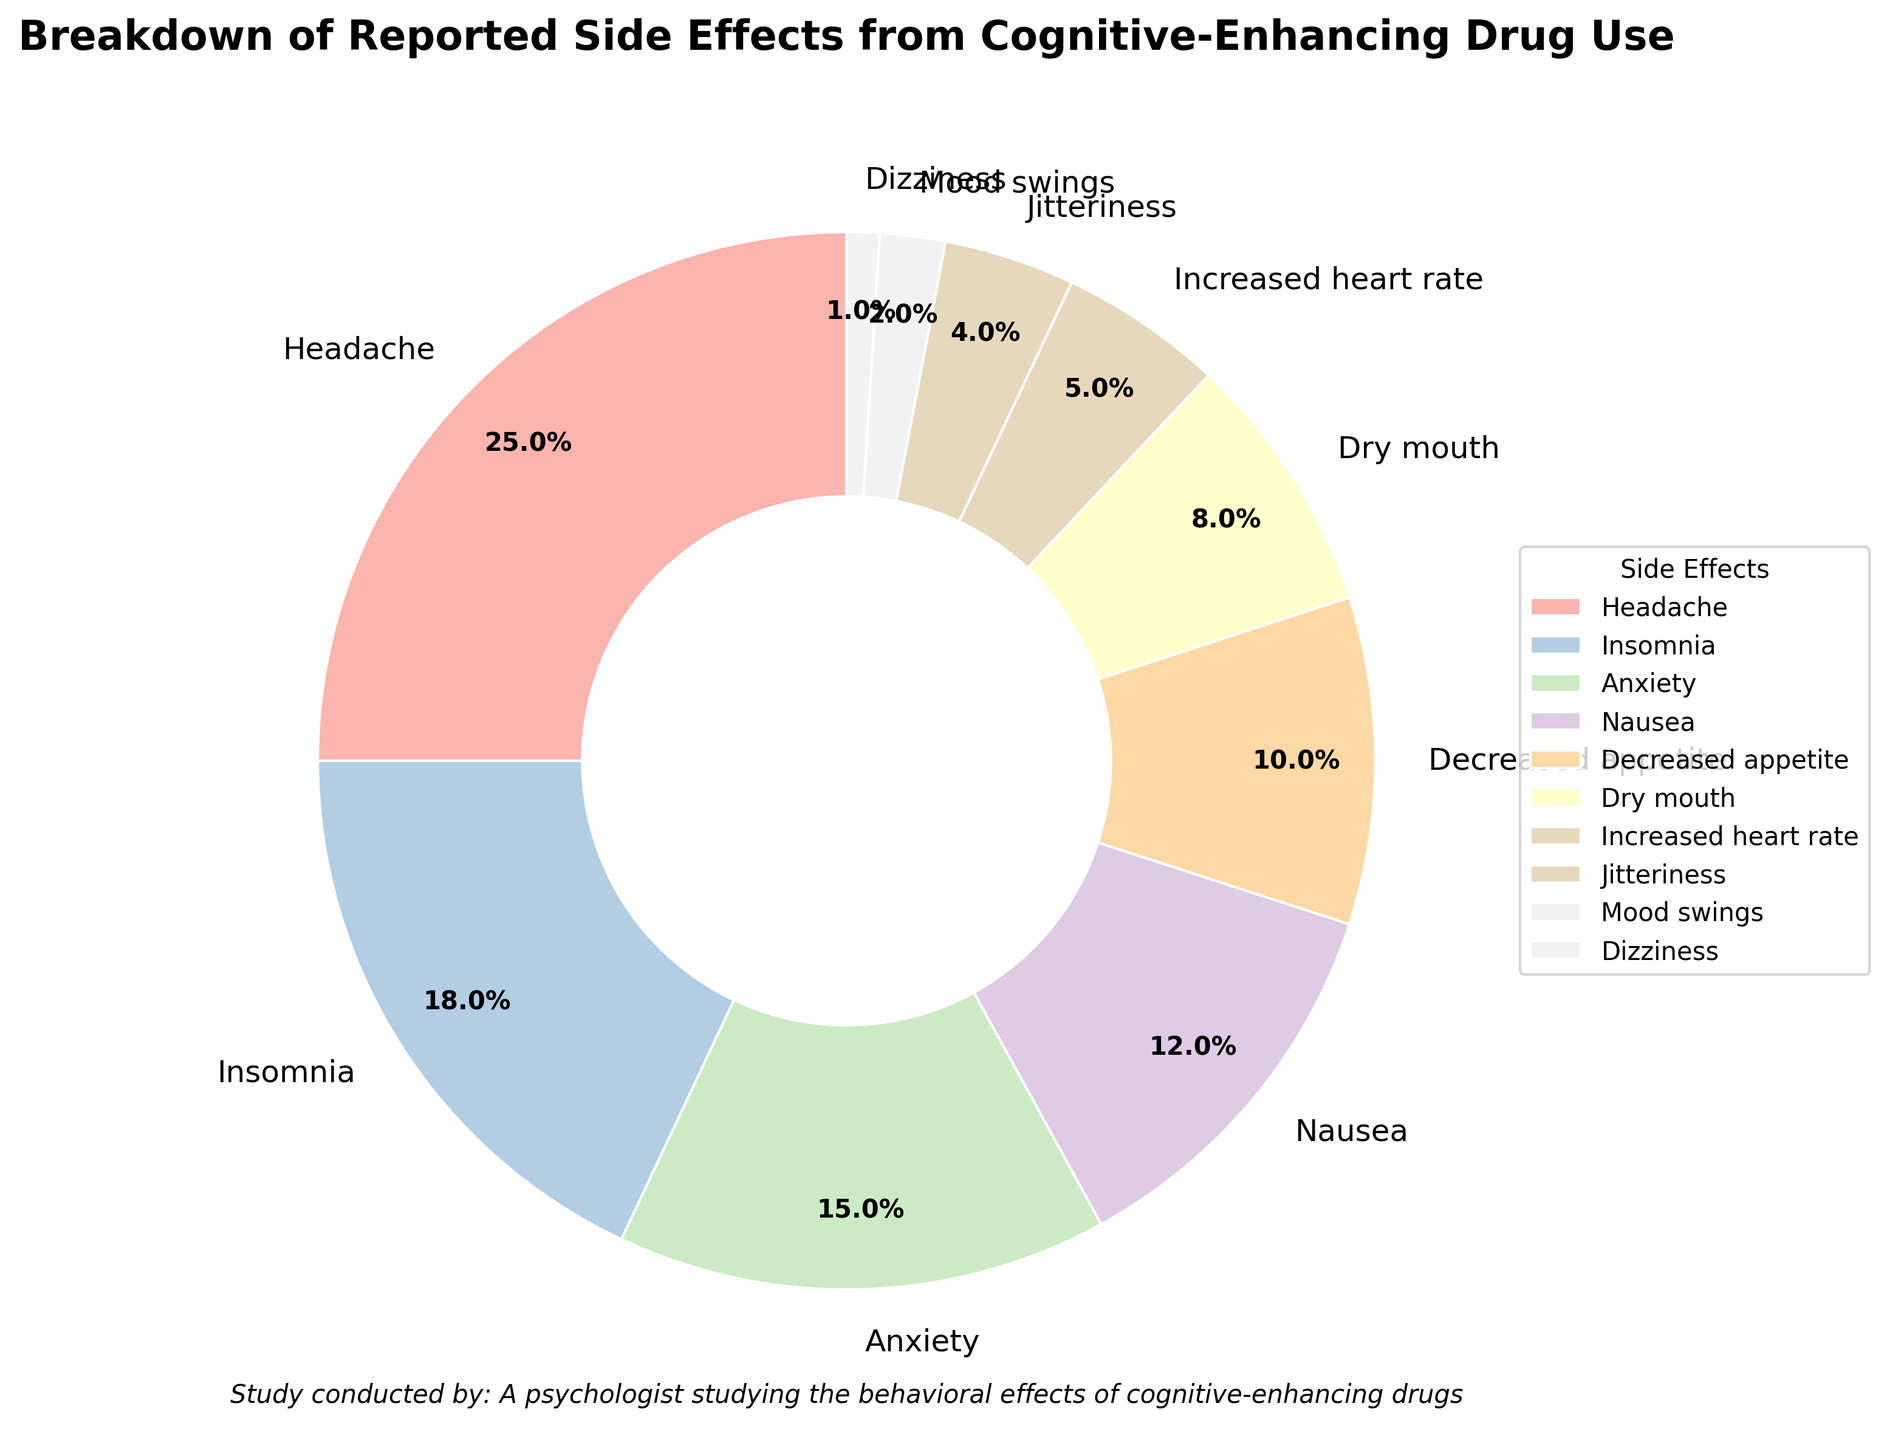What percentage of reported side effects does Insomnia account for? The pie chart indicates the percentage of each reported side effect. Insomnia is labeled with 18%.
Answer: 18% Which side effect is reported more frequently: Nausea or Dry mouth? By comparing the percentages labeled for Nausea and Dry mouth, Nausea is 12% and Dry mouth is 8%.
Answer: Nausea What is the sum of the percentages for Anxiety, Decreased appetite, and Increased heart rate? Adding the percentages together requires looking at the labeled values: Anxiety (15%), Decreased appetite (10%), and Increased heart rate (5%). So, 15 + 10 + 5 = 30%
Answer: 30% Which side effect has the smallest percentage reported? By checking the smallest percentage label, Dizziness has the smallest value at 1%.
Answer: Dizziness What is the difference in percentage between the most and least common side effects? The most common side effect is Headache at 25% and the least common is Dizziness at 1%. The difference is 25% - 1% = 24%.
Answer: 24% How many side effects have a reported percentage of 10% or higher? From the pie chart, the side effects with 10% or higher are: Headache (25%), Insomnia (18%), Anxiety (15%), Nausea (12%), and Decreased appetite (10%). There are 5 such side effects.
Answer: 5 Which side effect is represented with the darkest color in the chart? The pie chart utilizes colors from a palette, and the darkest shade is used for Headache which is represented with the largest wedge.
Answer: Headache What is the average percentage of the four least common side effects? The four least common side effects are Jitteriness (4%), Mood swings (2%), and Dizziness (1%). Adding them up, we get 4 + 2 + 1 = 7%. Dividing by 4, 7/4 = 1.75%.
Answer: 1.75% Are there more side effects reported above or below 10%? Count the side effects above 10%: Headache, Insomnia, Anxiety, Nausea, Decreased appetite (5 side effects). Side effects below 10% are: Dry mouth, Increased heart rate, Jitteriness, Mood swings, and Dizziness (5 side effects). Both are equal.
Answer: Equal 